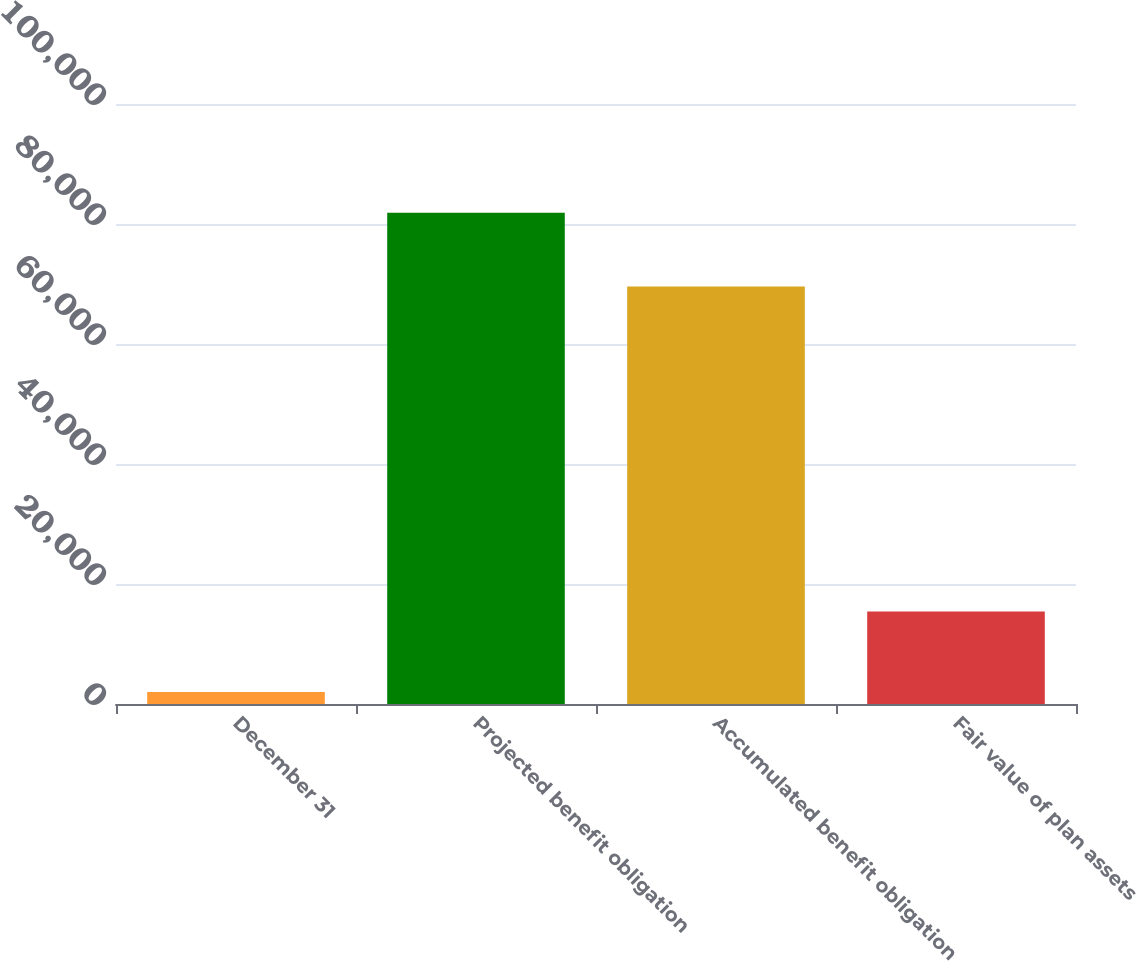Convert chart to OTSL. <chart><loc_0><loc_0><loc_500><loc_500><bar_chart><fcel>December 31<fcel>Projected benefit obligation<fcel>Accumulated benefit obligation<fcel>Fair value of plan assets<nl><fcel>2010<fcel>81867<fcel>69591<fcel>15427<nl></chart> 